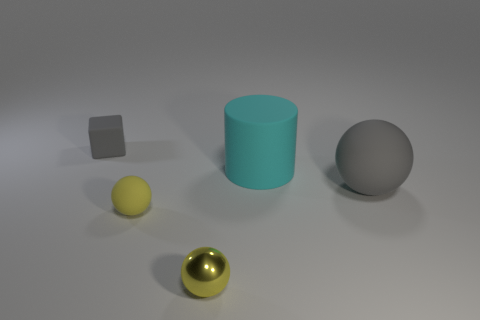Add 1 large red rubber cubes. How many objects exist? 6 Subtract all blocks. How many objects are left? 4 Add 4 tiny gray things. How many tiny gray things are left? 5 Add 5 cylinders. How many cylinders exist? 6 Subtract 0 cyan balls. How many objects are left? 5 Subtract all large purple rubber cylinders. Subtract all small yellow matte objects. How many objects are left? 4 